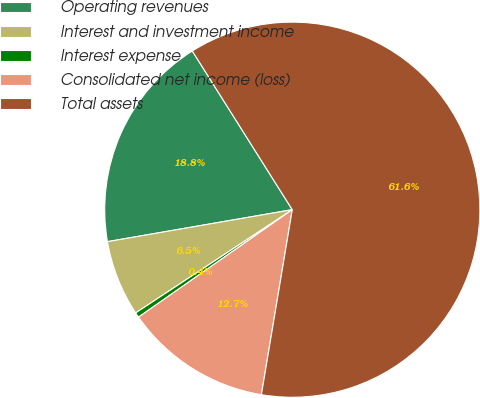Convert chart to OTSL. <chart><loc_0><loc_0><loc_500><loc_500><pie_chart><fcel>Operating revenues<fcel>Interest and investment income<fcel>Interest expense<fcel>Consolidated net income (loss)<fcel>Total assets<nl><fcel>18.78%<fcel>6.55%<fcel>0.43%<fcel>12.66%<fcel>61.58%<nl></chart> 